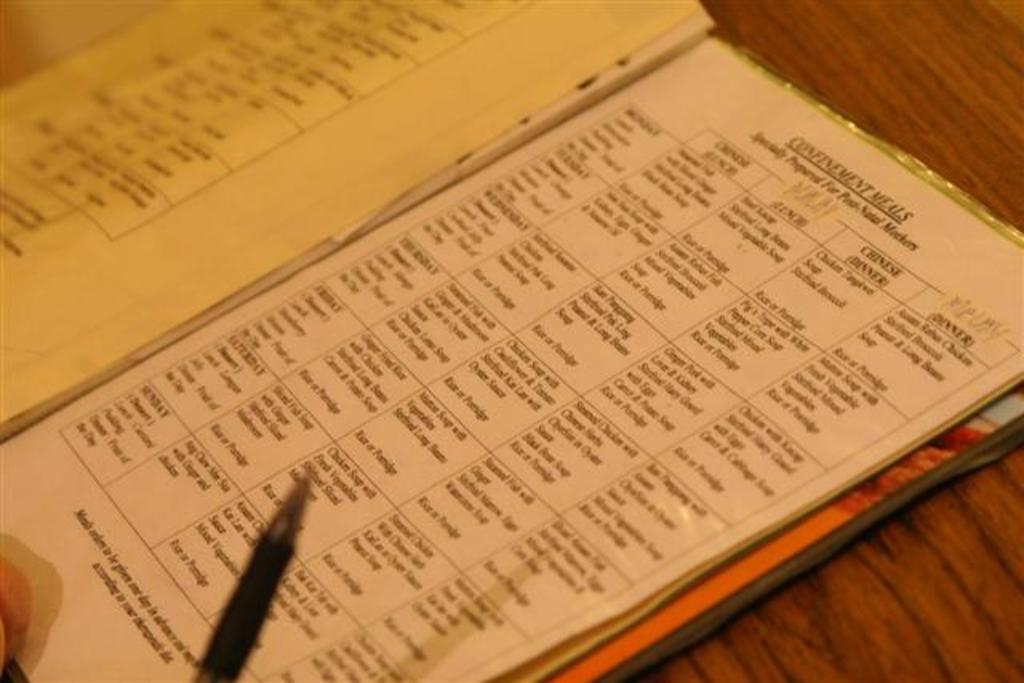<image>
Offer a succinct explanation of the picture presented. A menu list that is labeled confinement meals. 